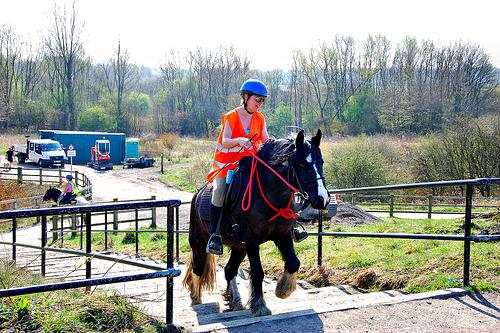In a single sentence, describe what's happening in the picture. A helmeted lady wearing an orange vest rides a horse up stairs, accompanied by leafless trees and black stairway railings. Briefly explain what's happening in the image by stating the main subject and their action. A person in protective gear is expertly riding a horse up a flight of stairs, with black railings and tall trees nearby. Offer a brief account of the key subject in the image and what they're doing. A woman donning a helmet and orange vest rides a horse with red reins as they ascend a staircase lined with black railings and surrounded by tall trees. Summarize the main action taking place in the image. A woman clad in safety equipment is riding her horse up a staircase with black metal railings, surrounded by tall, leafless trees. Concisely state the main focus of the image and the actions taking place. A woman in a blue helmet and orange safety vest is riding a horse that's walking up a staircase, amidst black railings and towering trees without leaves. Mention the main elements in the image and their interaction. A woman wearing a blue helmet and orange vest is riding a horse with red reins, walking up a staircase with black railings, surrounded by tall bare trees. Write a concise description of the central subject and their activity in the image. A woman in a blue helmet and orange vest rides a horse with red reins up a staircase amidst a backdrop of leafless trees and metal railings. Quickly summarize the main event occurring in the picture. A woman wearing a helmet and orange vest is riding a horse with red reins up a staircase, with the setting featuring metal railings and leafless trees. Describe the core activity taking place in the image. The image showcases a woman in safety attire expertly riding a horse up a staircase, enveloped by a scene of metal railings and tall, bare trees. Provide a brief summary of the scene depicted in the image. The image shows a woman in safety gear riding a horse up a flight of stairs, with bare trees and metal railings around them. 